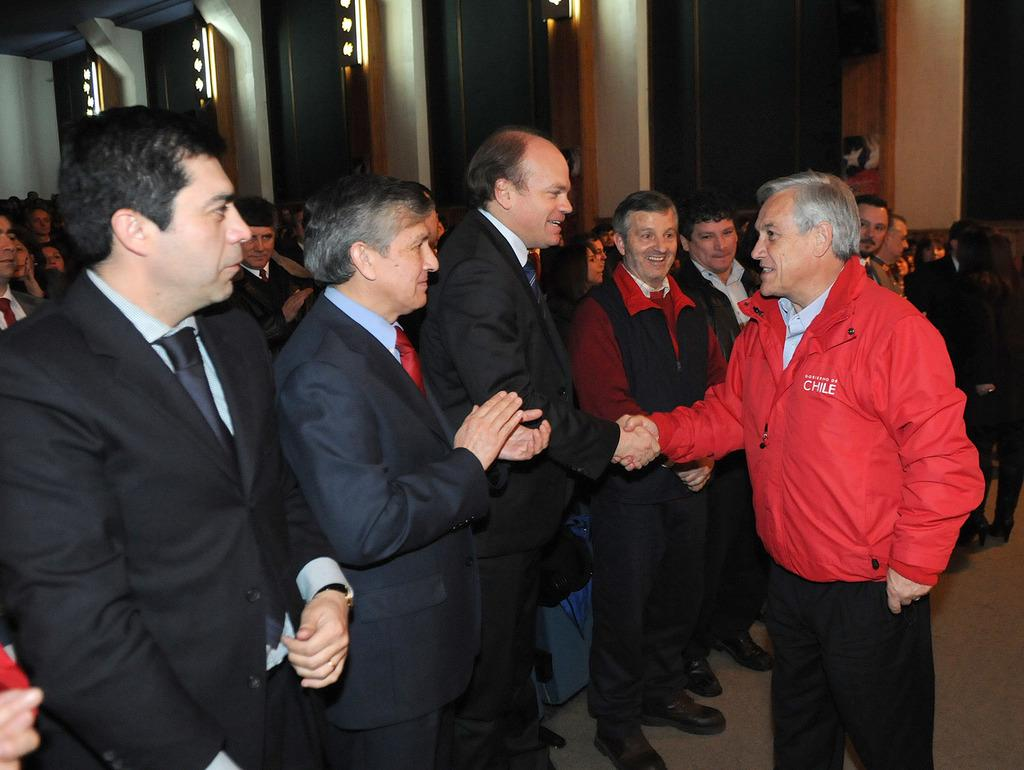What are the two people in the image doing? The two people in the image are shaking hands. What is the person on the right side of the image wearing? The person on the right side of the image is wearing a black suit. Are there any other people present in the image besides the two shaking hands? Yes, there are other people present in the image. What brand of toothpaste is being advertised by the person in the black suit? There is no toothpaste or advertisement present in the image. What type of trade agreement is being discussed by the people in the image? There is no indication of a trade agreement or discussion in the image. 